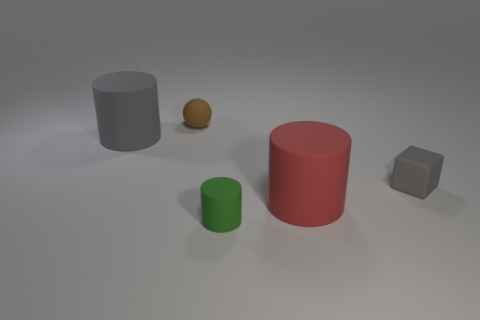Subtract all gray cylinders. How many cylinders are left? 2 Add 5 green things. How many objects exist? 10 Subtract all red cylinders. How many cylinders are left? 2 Add 4 large rubber objects. How many large rubber objects are left? 6 Add 3 tiny balls. How many tiny balls exist? 4 Subtract 0 cyan cylinders. How many objects are left? 5 Subtract all cubes. How many objects are left? 4 Subtract 1 cylinders. How many cylinders are left? 2 Subtract all yellow cylinders. Subtract all cyan blocks. How many cylinders are left? 3 Subtract all tiny blocks. Subtract all tiny brown rubber things. How many objects are left? 3 